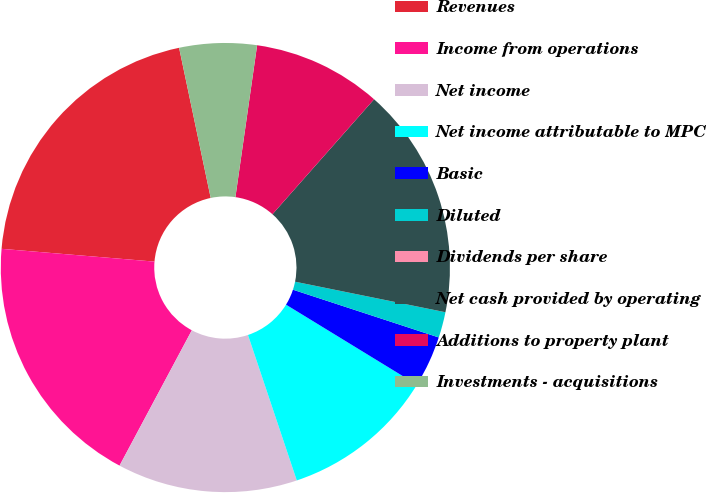Convert chart to OTSL. <chart><loc_0><loc_0><loc_500><loc_500><pie_chart><fcel>Revenues<fcel>Income from operations<fcel>Net income<fcel>Net income attributable to MPC<fcel>Basic<fcel>Diluted<fcel>Dividends per share<fcel>Net cash provided by operating<fcel>Additions to property plant<fcel>Investments - acquisitions<nl><fcel>20.37%<fcel>18.52%<fcel>12.96%<fcel>11.11%<fcel>3.7%<fcel>1.85%<fcel>0.0%<fcel>16.67%<fcel>9.26%<fcel>5.56%<nl></chart> 